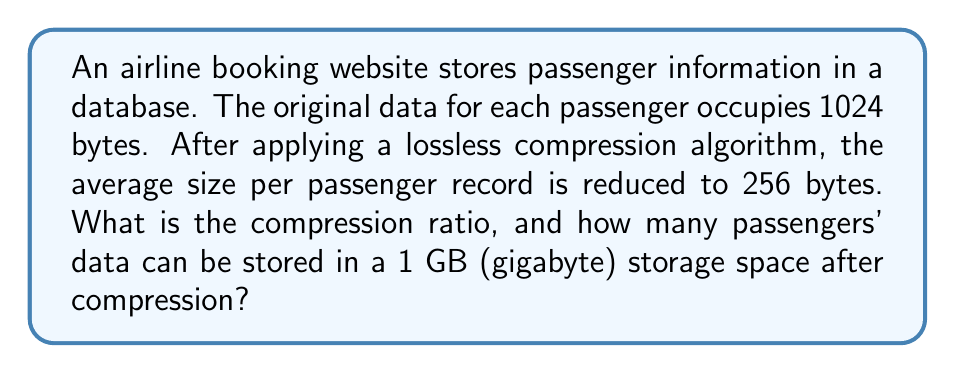Help me with this question. To solve this problem, we need to follow these steps:

1. Calculate the compression ratio:
   The compression ratio is defined as the ratio of the uncompressed size to the compressed size.
   
   $$\text{Compression Ratio} = \frac{\text{Uncompressed Size}}{\text{Compressed Size}}$$
   
   $$\text{Compression Ratio} = \frac{1024 \text{ bytes}}{256 \text{ bytes}} = 4$$

2. Convert 1 GB to bytes:
   1 GB = 1 gigabyte = $1 \times 2^{30}$ bytes = 1,073,741,824 bytes

3. Calculate the number of compressed passenger records that can fit in 1 GB:
   $$\text{Number of Records} = \frac{\text{Total Storage Space}}{\text{Compressed Record Size}}$$
   
   $$\text{Number of Records} = \frac{1,073,741,824 \text{ bytes}}{256 \text{ bytes per record}}$$
   
   $$\text{Number of Records} = 4,194,304$$

Therefore, after compression, 4,194,304 passenger records can be stored in 1 GB of storage space.
Answer: The compression ratio is 4:1, and 4,194,304 compressed passenger records can be stored in 1 GB of storage space. 